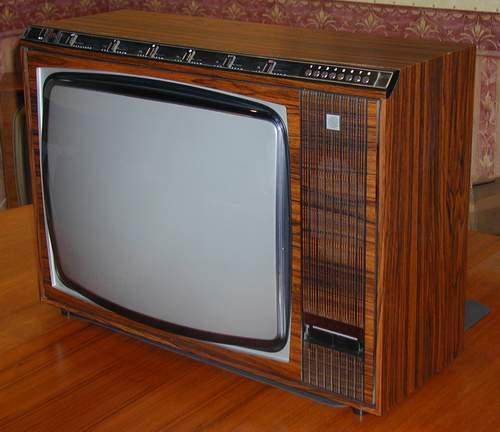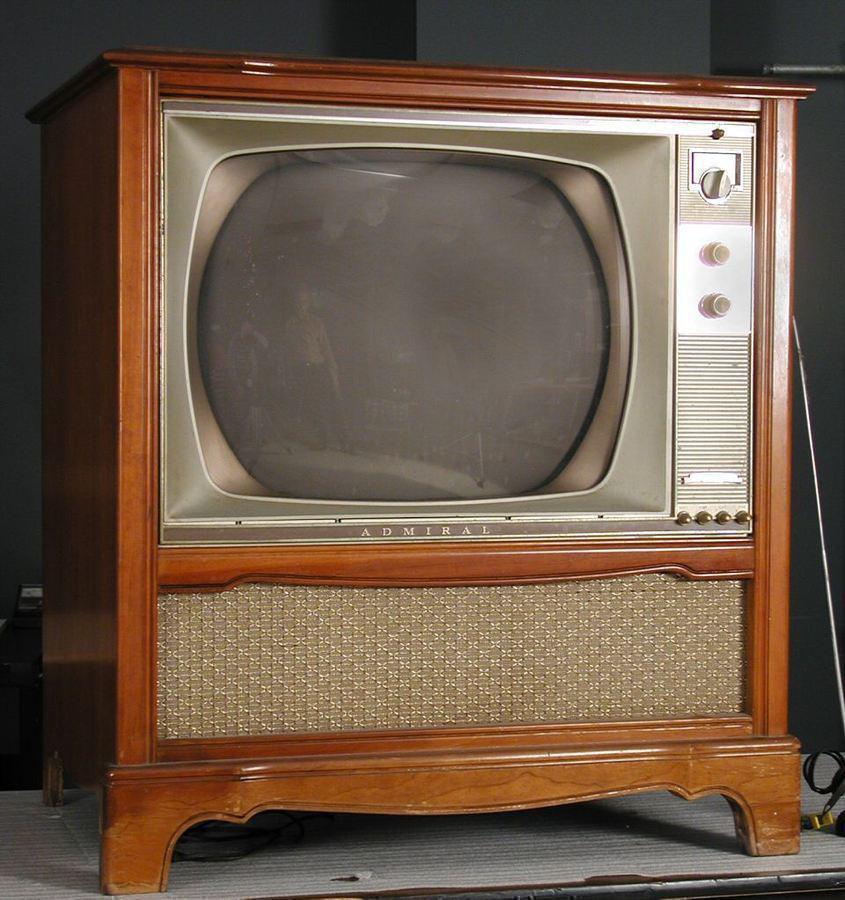The first image is the image on the left, the second image is the image on the right. Considering the images on both sides, is "The TV on the left is sitting on a wood surface, and the TV on the right is a console style with its screen in a wooden case with no panel under the screen and with slender legs." valid? Answer yes or no. No. The first image is the image on the left, the second image is the image on the right. Considering the images on both sides, is "One of the televisions has an underneath speaker." valid? Answer yes or no. Yes. 